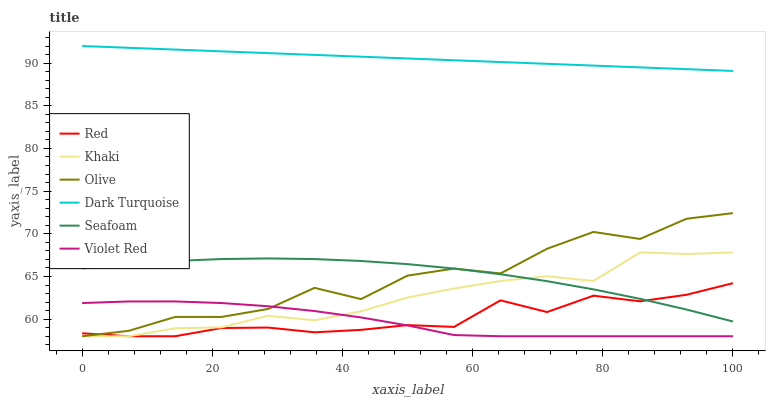Does Violet Red have the minimum area under the curve?
Answer yes or no. Yes. Does Dark Turquoise have the maximum area under the curve?
Answer yes or no. Yes. Does Khaki have the minimum area under the curve?
Answer yes or no. No. Does Khaki have the maximum area under the curve?
Answer yes or no. No. Is Dark Turquoise the smoothest?
Answer yes or no. Yes. Is Olive the roughest?
Answer yes or no. Yes. Is Khaki the smoothest?
Answer yes or no. No. Is Khaki the roughest?
Answer yes or no. No. Does Violet Red have the lowest value?
Answer yes or no. Yes. Does Dark Turquoise have the lowest value?
Answer yes or no. No. Does Dark Turquoise have the highest value?
Answer yes or no. Yes. Does Khaki have the highest value?
Answer yes or no. No. Is Khaki less than Dark Turquoise?
Answer yes or no. Yes. Is Seafoam greater than Violet Red?
Answer yes or no. Yes. Does Khaki intersect Violet Red?
Answer yes or no. Yes. Is Khaki less than Violet Red?
Answer yes or no. No. Is Khaki greater than Violet Red?
Answer yes or no. No. Does Khaki intersect Dark Turquoise?
Answer yes or no. No. 